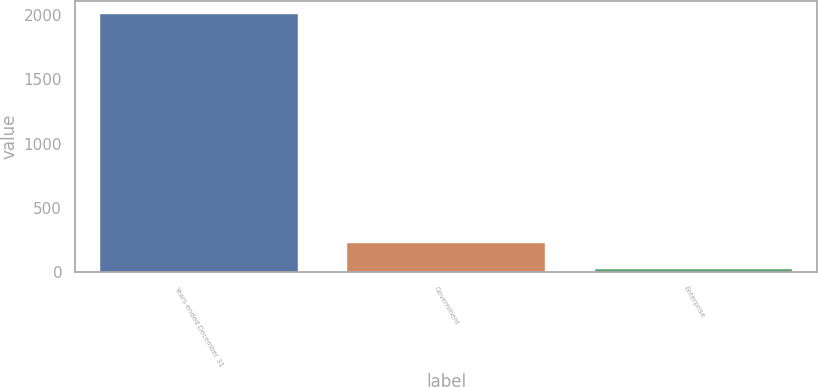<chart> <loc_0><loc_0><loc_500><loc_500><bar_chart><fcel>Years ended December 31<fcel>Government<fcel>Enterprise<nl><fcel>2011<fcel>225.4<fcel>27<nl></chart> 